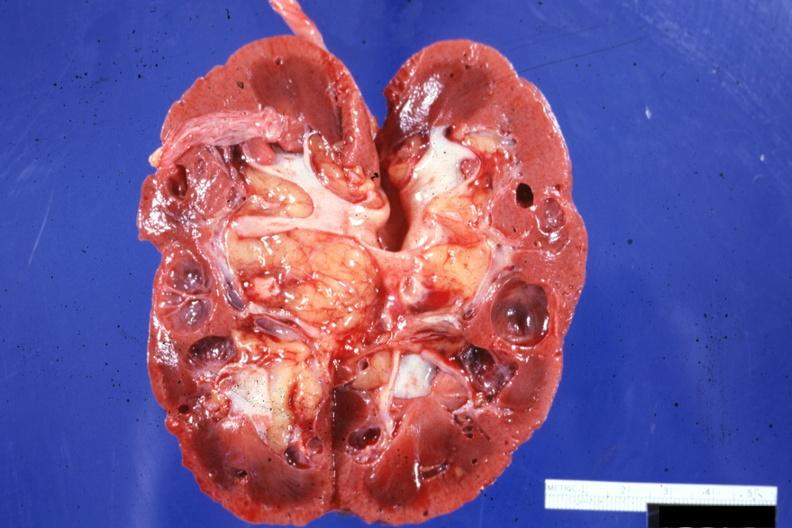s kidney present?
Answer the question using a single word or phrase. Yes 